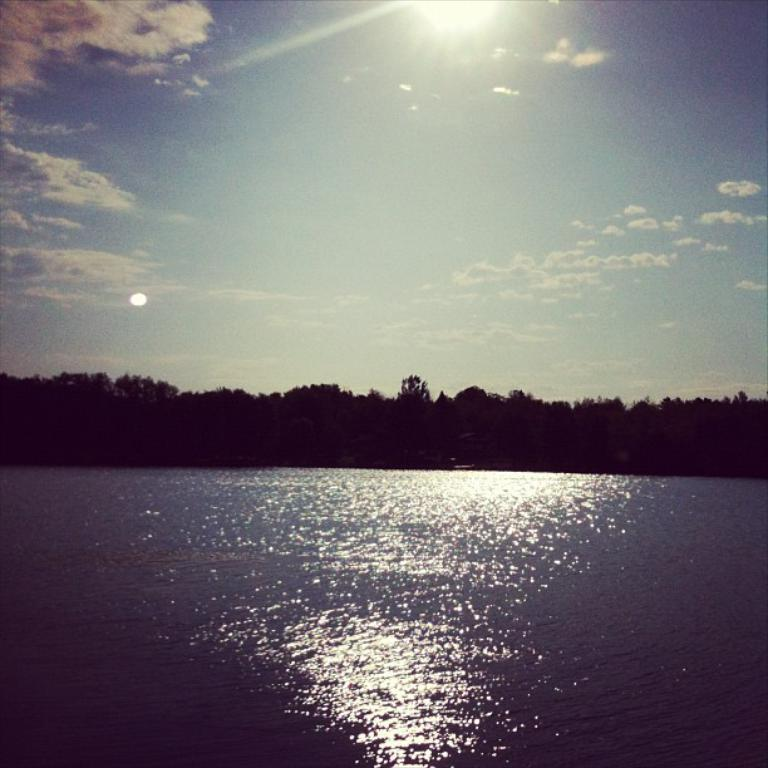What type of vegetation can be seen in the image? There are trees in the image. What natural element is visible in the image besides the trees? There is water visible in the image. What can be seen in the background of the image? The sky is visible in the background of the image. What is the condition of the sky in the image? Clouds are present in the sky. Can you tell me how many zippers are visible on the trees in the image? There are no zippers present on the trees in the image; they are natural vegetation. Are there any dinosaurs visible in the image? There are no dinosaurs present in the image; it features trees, water, and a sky with clouds. 